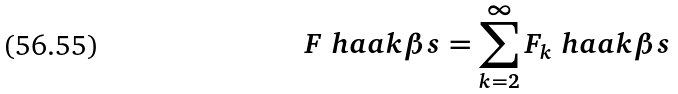<formula> <loc_0><loc_0><loc_500><loc_500>F \ h a a k { \beta s } = \sum _ { k = 2 } ^ { \infty } F _ { k } \ h a a k { \beta s }</formula> 